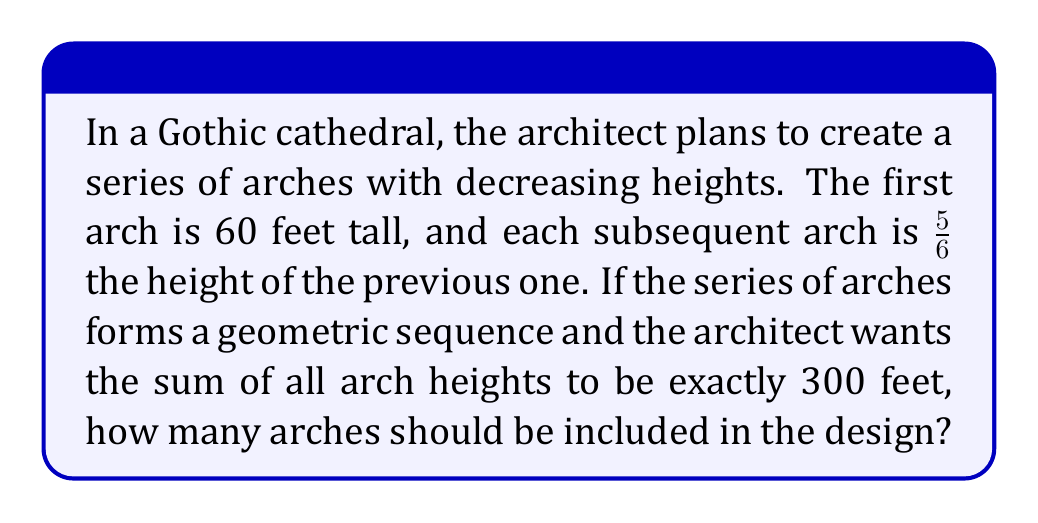Can you answer this question? Let's approach this step-by-step:

1) We have a geometric series where:
   First term, $a = 60$ feet
   Common ratio, $r = 5/6$

2) We need to find $n$ (number of terms) such that the sum of the series is 300 feet.

3) The formula for the sum of a geometric series is:

   $$S_n = \frac{a(1-r^n)}{1-r}$$

   Where $S_n$ is the sum, $a$ is the first term, $r$ is the common ratio, and $n$ is the number of terms.

4) Substituting our known values:

   $$300 = \frac{60(1-(5/6)^n)}{1-(5/6)}$$

5) Simplify:

   $$300 = 360(1-(5/6)^n)$$

6) Divide both sides by 360:

   $$5/6 = 1-(5/6)^n$$

7) Subtract both sides from 1:

   $$1/6 = (5/6)^n$$

8) Take the logarithm of both sides:

   $$\log(1/6) = n\log(5/6)$$

9) Solve for $n$:

   $$n = \frac{\log(1/6)}{\log(5/6)} \approx 10.04$$

10) Since we can't have a fractional number of arches, we round down to 10.

11) To verify:
    $$S_{10} = \frac{60(1-(5/6)^{10})}{1-(5/6)} \approx 299.97\text{ feet}$$
    
    This is very close to 300 feet, confirming our answer.
Answer: 10 arches 